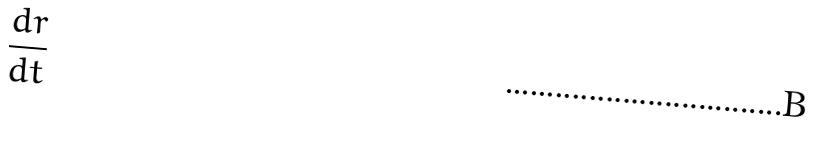Convert formula to latex. <formula><loc_0><loc_0><loc_500><loc_500>\frac { d r } { d t }</formula> 